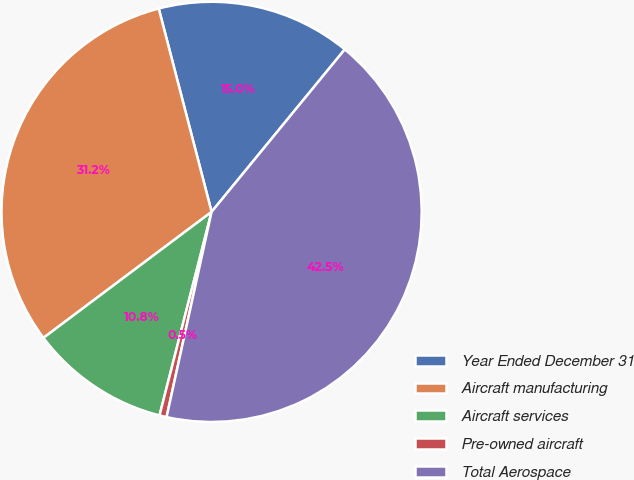Convert chart to OTSL. <chart><loc_0><loc_0><loc_500><loc_500><pie_chart><fcel>Year Ended December 31<fcel>Aircraft manufacturing<fcel>Aircraft services<fcel>Pre-owned aircraft<fcel>Total Aerospace<nl><fcel>14.98%<fcel>31.19%<fcel>10.78%<fcel>0.55%<fcel>42.51%<nl></chart> 